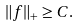Convert formula to latex. <formula><loc_0><loc_0><loc_500><loc_500>\| f \| _ { + } \geq C .</formula> 